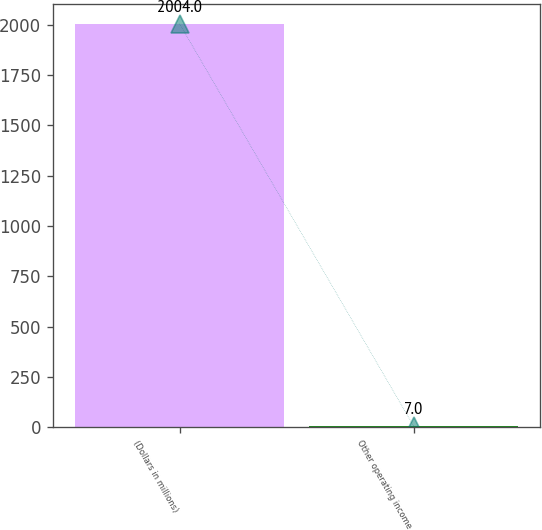<chart> <loc_0><loc_0><loc_500><loc_500><bar_chart><fcel>(Dollars in millions)<fcel>Other operating income<nl><fcel>2004<fcel>7<nl></chart> 